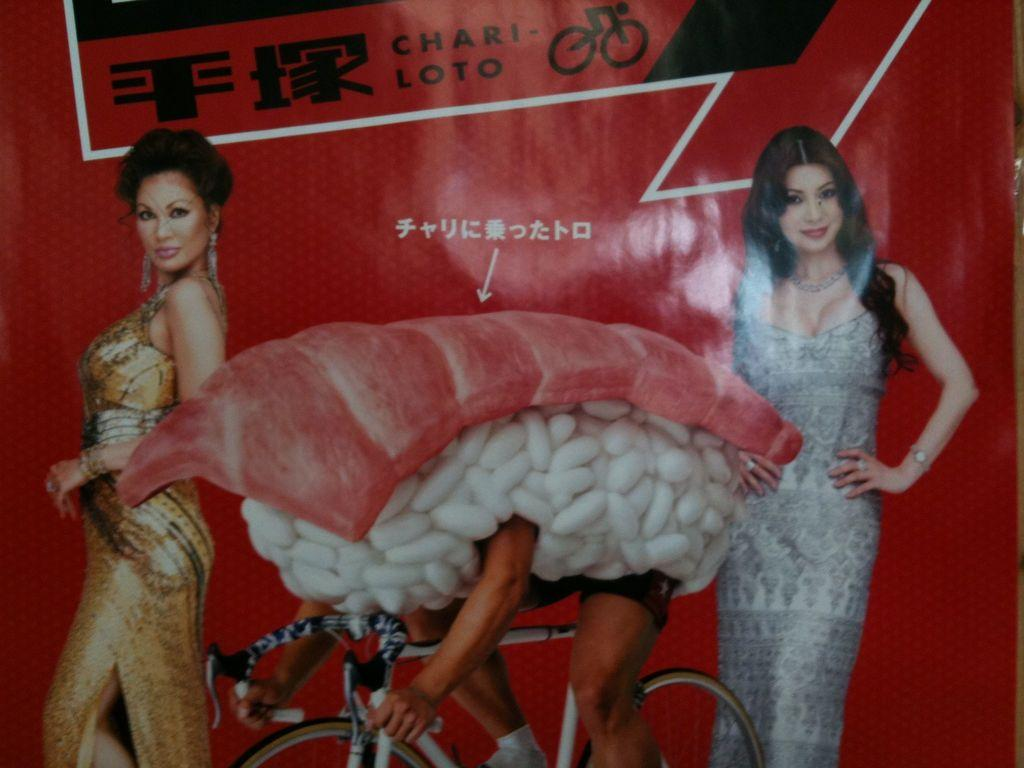How many people are in the foreground of the image? There are two women and a man on a cycle in the foreground of the image. What are the women doing in the image? The information provided does not specify what the women are doing. What is the man on the cycle doing in the image? The man on the cycle is in the foreground of the image, but his actions are not specified. What type of food is visible in the image? Meat is visible in the image. What else is present in the image besides the people and meat? Capsules are present in the image. How many trees are visible in the image? There is no mention of trees in the provided facts, so we cannot determine how many trees are visible in the image. 